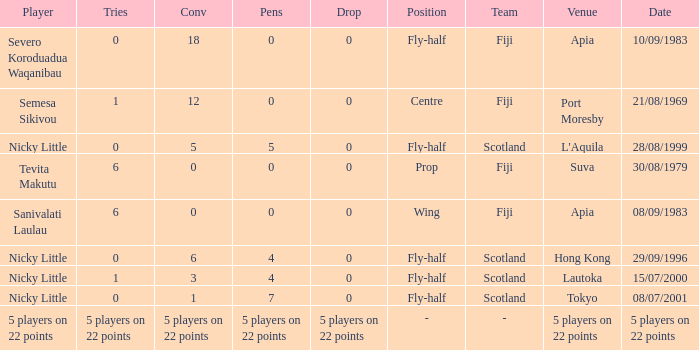How many drops did Nicky Little have in Hong Kong? 0.0. 